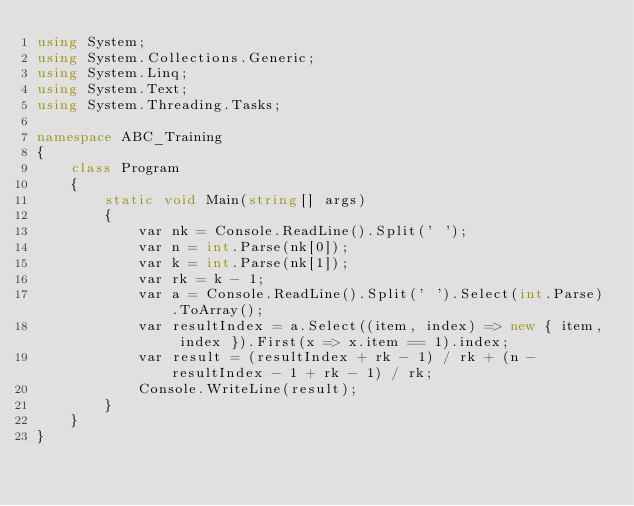Convert code to text. <code><loc_0><loc_0><loc_500><loc_500><_C#_>using System;
using System.Collections.Generic;
using System.Linq;
using System.Text;
using System.Threading.Tasks;

namespace ABC_Training
{
    class Program
    {
        static void Main(string[] args)
        {
            var nk = Console.ReadLine().Split(' ');
            var n = int.Parse(nk[0]);
            var k = int.Parse(nk[1]);
            var rk = k - 1;
            var a = Console.ReadLine().Split(' ').Select(int.Parse).ToArray();
            var resultIndex = a.Select((item, index) => new { item, index }).First(x => x.item == 1).index;
            var result = (resultIndex + rk - 1) / rk + (n - resultIndex - 1 + rk - 1) / rk;
            Console.WriteLine(result);
        }
    }
}
</code> 